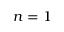<formula> <loc_0><loc_0><loc_500><loc_500>n = 1</formula> 